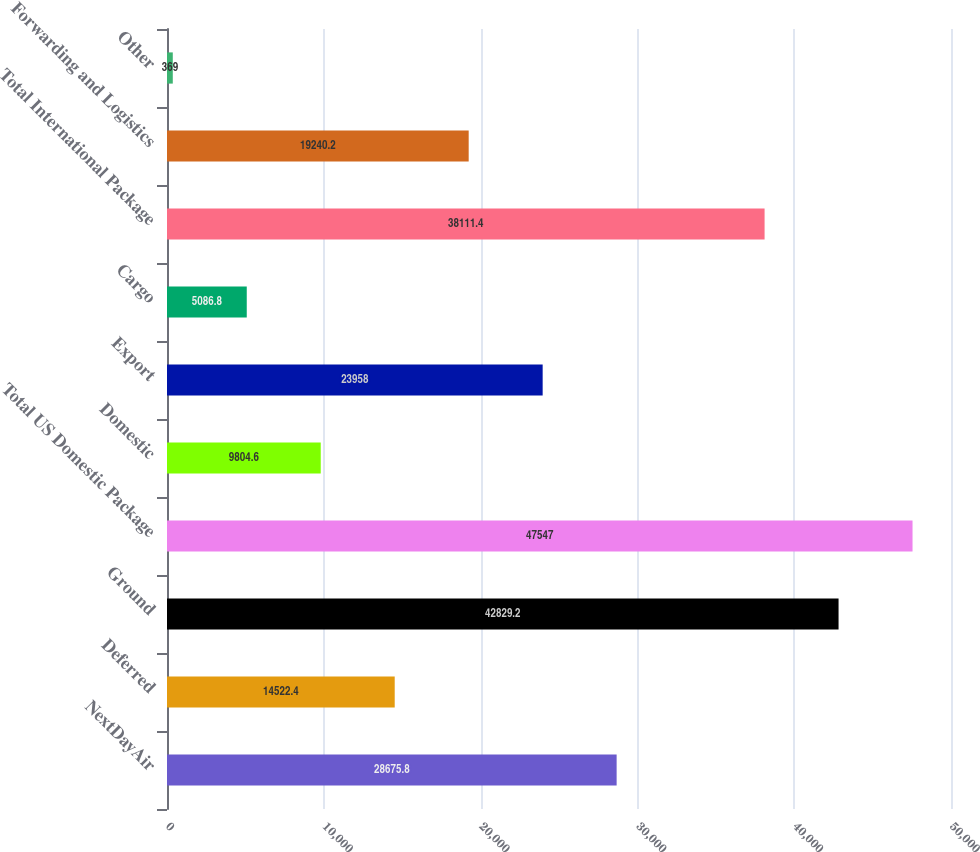Convert chart to OTSL. <chart><loc_0><loc_0><loc_500><loc_500><bar_chart><fcel>NextDayAir<fcel>Deferred<fcel>Ground<fcel>Total US Domestic Package<fcel>Domestic<fcel>Export<fcel>Cargo<fcel>Total International Package<fcel>Forwarding and Logistics<fcel>Other<nl><fcel>28675.8<fcel>14522.4<fcel>42829.2<fcel>47547<fcel>9804.6<fcel>23958<fcel>5086.8<fcel>38111.4<fcel>19240.2<fcel>369<nl></chart> 